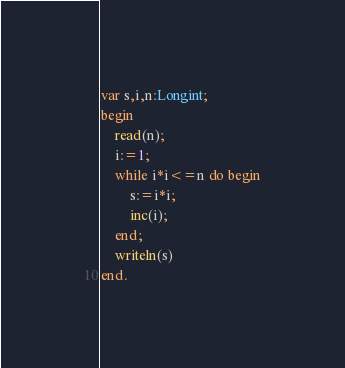Convert code to text. <code><loc_0><loc_0><loc_500><loc_500><_Pascal_>var s,i,n:Longint;
begin
	read(n);
	i:=1;
	while i*i<=n do begin
		s:=i*i;
		inc(i);
	end;
	writeln(s)
end.
</code> 